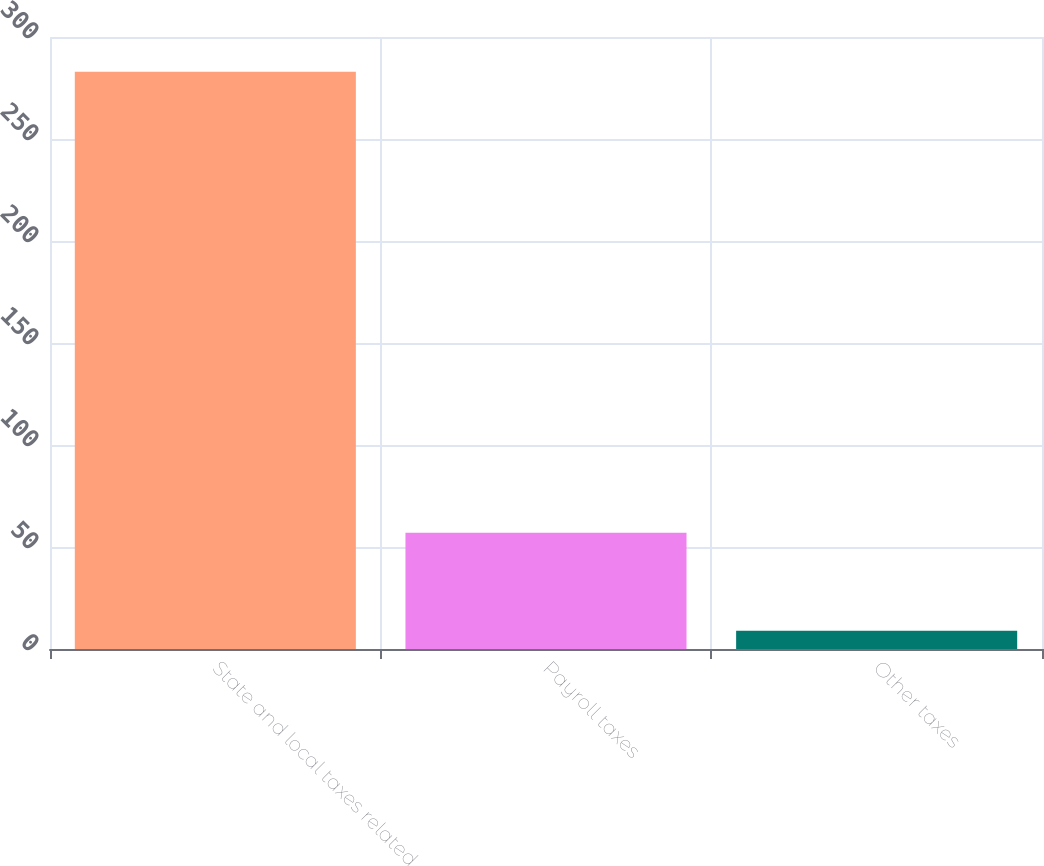Convert chart. <chart><loc_0><loc_0><loc_500><loc_500><bar_chart><fcel>State and local taxes related<fcel>Payroll taxes<fcel>Other taxes<nl><fcel>283<fcel>57<fcel>9<nl></chart> 